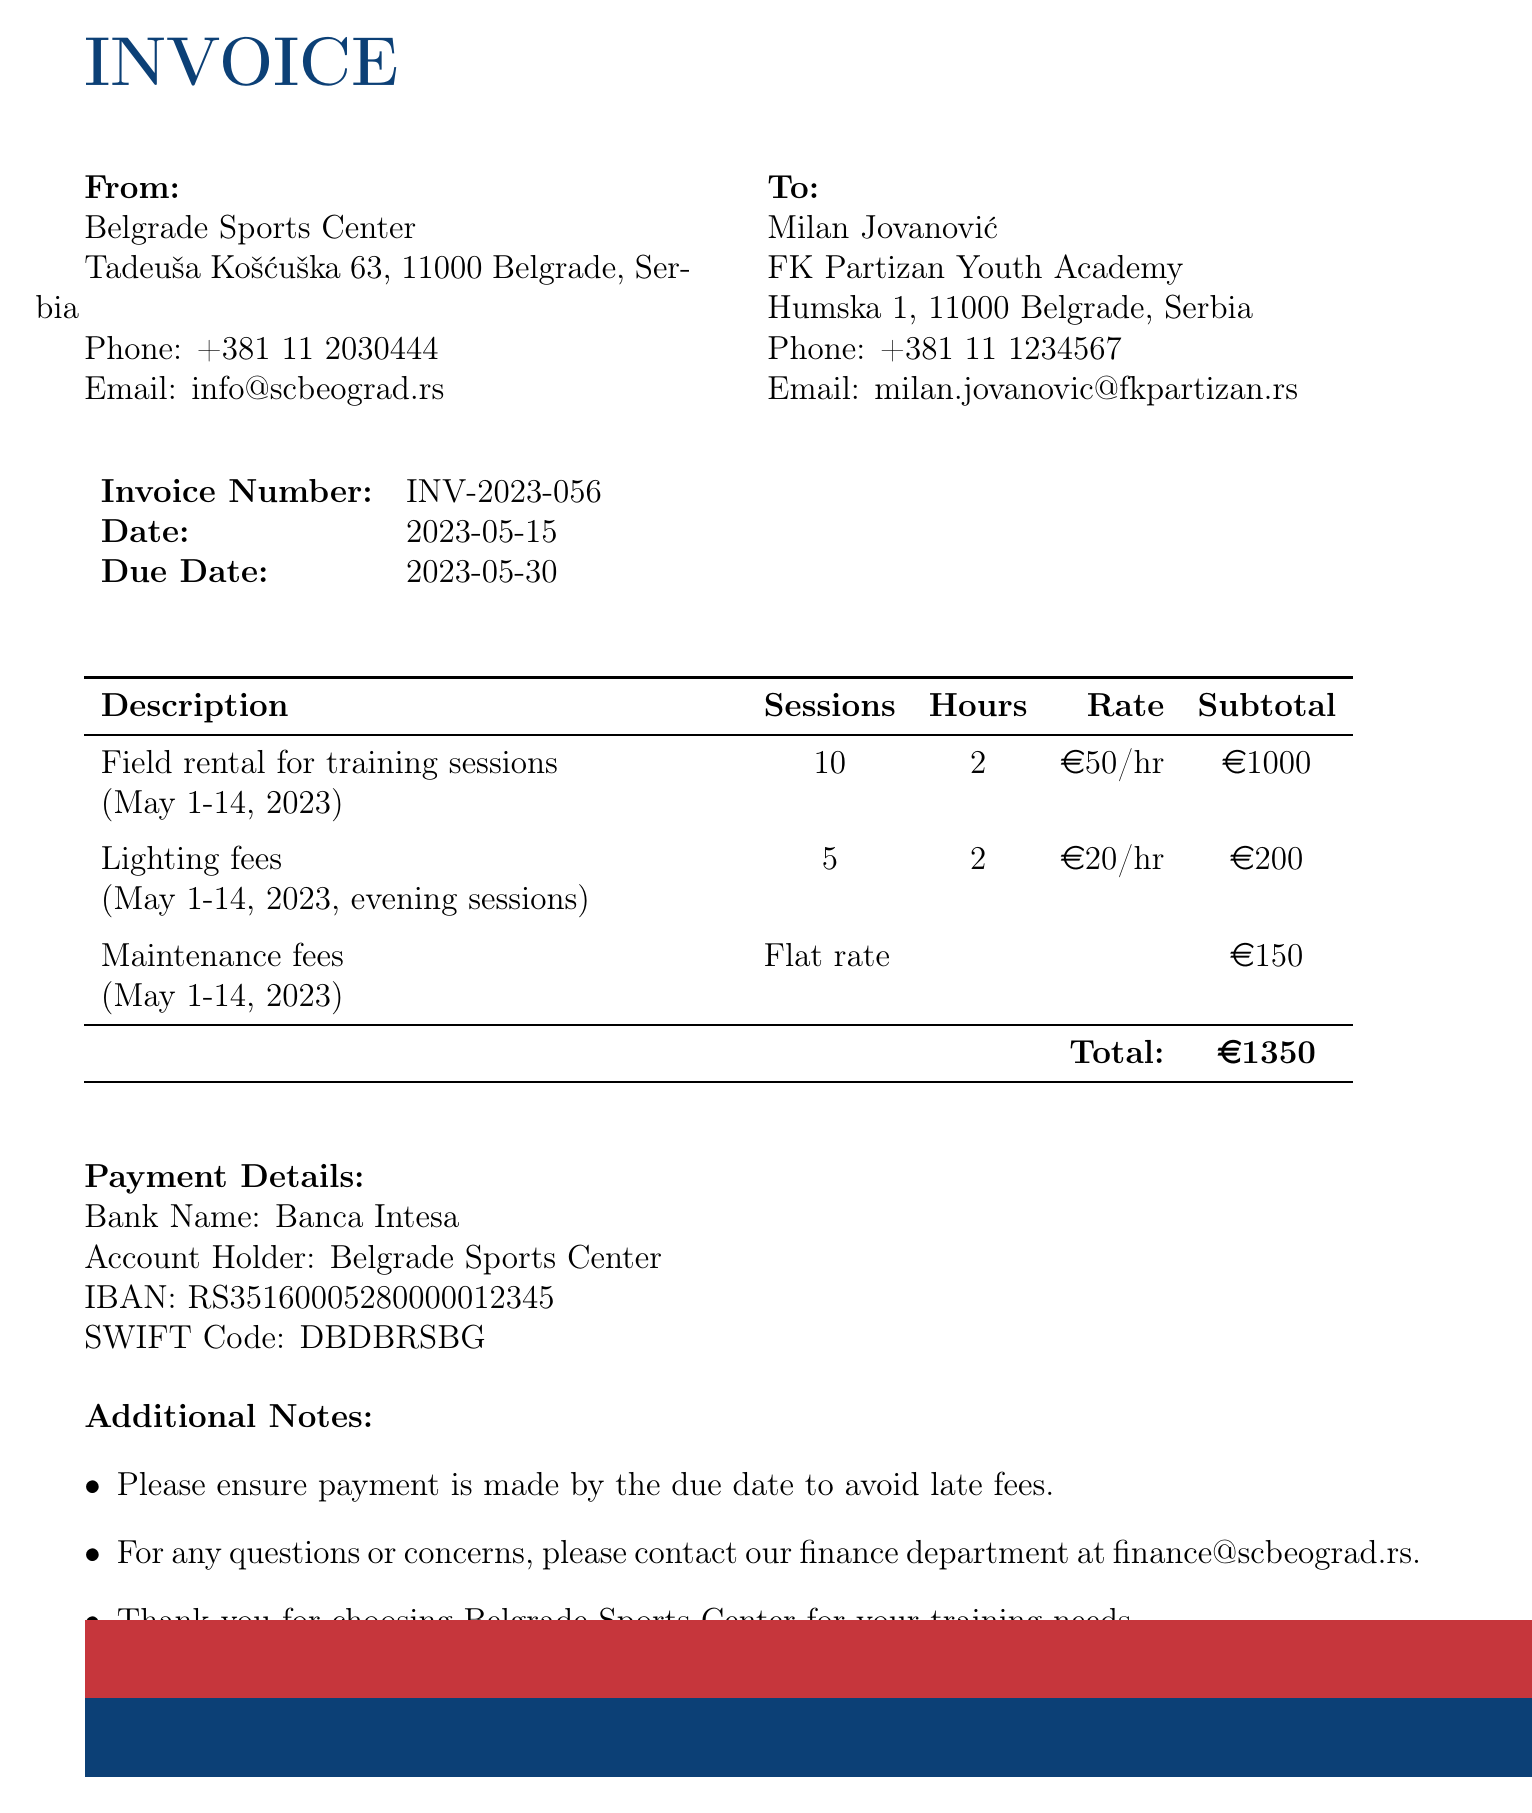what is the invoice number? The invoice number is labeled clearly in the document for easy reference.
Answer: INV-2023-056 who is the coach? The document specifies the name of the coach responsible for the rental as part of the recipient's details.
Answer: Milan Jovanović what is the total amount due? The total amount is clearly stated at the bottom of the invoice, representing the sum of all rental items.
Answer: 1350 EUR how many training sessions were included? The number of training sessions is detailed under the field rental description in the invoice.
Answer: 10 sessions what is the due date for the payment? The due date is mentioned explicitly amongst the invoice details for payment reference.
Answer: 2023-05-30 what is the maintenance fee? The maintenance fee is listed separately in the invoice table which indicates its flat rate.
Answer: 150 EUR where is the field located? The location of the field is included under the field details section of the document.
Answer: Humska 1, 11000 Belgrade, Serbia what rates were applied for lighting fees? The invoice outlines specific rates for different services prominently among the rental items.
Answer: 20 EUR per hour what type of document is this? The document is specifically structured and branded, indicating its purpose and type clearly at the top.
Answer: Invoice 